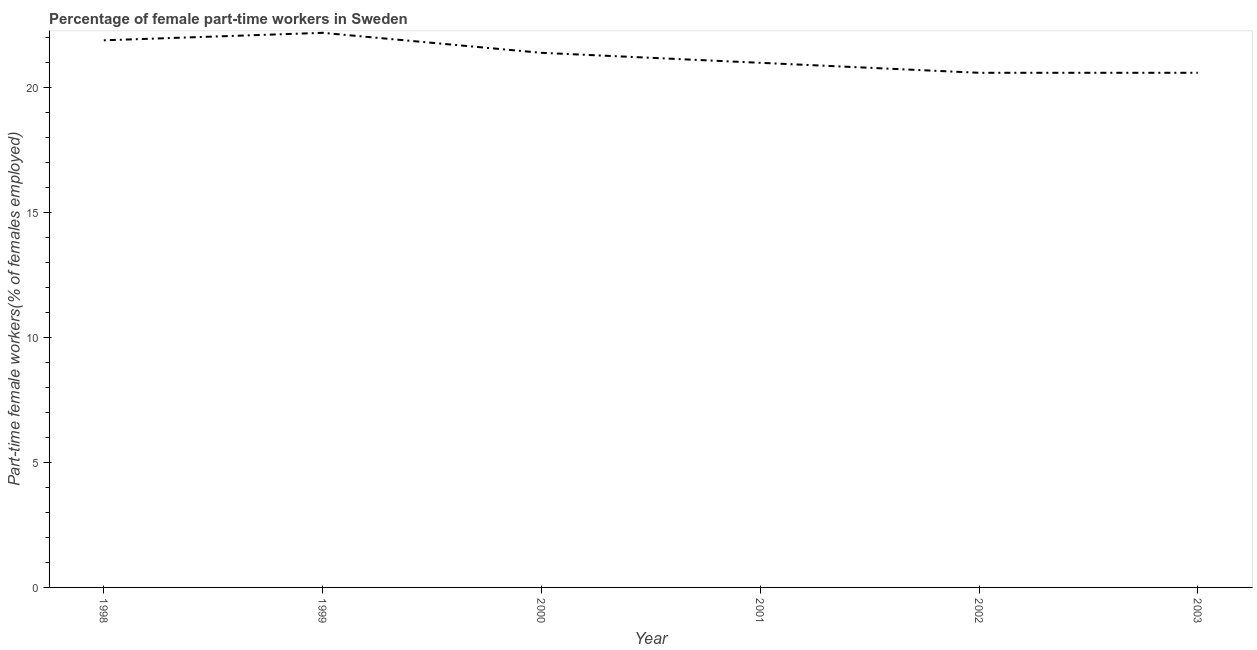What is the percentage of part-time female workers in 1999?
Your answer should be compact. 22.2. Across all years, what is the maximum percentage of part-time female workers?
Your answer should be very brief. 22.2. Across all years, what is the minimum percentage of part-time female workers?
Keep it short and to the point. 20.6. What is the sum of the percentage of part-time female workers?
Offer a terse response. 127.7. What is the difference between the percentage of part-time female workers in 1998 and 2003?
Ensure brevity in your answer.  1.3. What is the average percentage of part-time female workers per year?
Give a very brief answer. 21.28. What is the median percentage of part-time female workers?
Your answer should be compact. 21.2. Do a majority of the years between 2001 and 2000 (inclusive) have percentage of part-time female workers greater than 2 %?
Offer a terse response. No. What is the ratio of the percentage of part-time female workers in 1999 to that in 2001?
Your answer should be very brief. 1.06. What is the difference between the highest and the second highest percentage of part-time female workers?
Your response must be concise. 0.3. Is the sum of the percentage of part-time female workers in 2001 and 2002 greater than the maximum percentage of part-time female workers across all years?
Make the answer very short. Yes. What is the difference between the highest and the lowest percentage of part-time female workers?
Offer a terse response. 1.6. In how many years, is the percentage of part-time female workers greater than the average percentage of part-time female workers taken over all years?
Make the answer very short. 3. How many lines are there?
Provide a succinct answer. 1. How many years are there in the graph?
Ensure brevity in your answer.  6. Does the graph contain any zero values?
Your answer should be compact. No. Does the graph contain grids?
Your answer should be compact. No. What is the title of the graph?
Your answer should be very brief. Percentage of female part-time workers in Sweden. What is the label or title of the Y-axis?
Your answer should be very brief. Part-time female workers(% of females employed). What is the Part-time female workers(% of females employed) of 1998?
Offer a terse response. 21.9. What is the Part-time female workers(% of females employed) of 1999?
Offer a very short reply. 22.2. What is the Part-time female workers(% of females employed) of 2000?
Provide a succinct answer. 21.4. What is the Part-time female workers(% of females employed) in 2001?
Make the answer very short. 21. What is the Part-time female workers(% of females employed) of 2002?
Offer a terse response. 20.6. What is the Part-time female workers(% of females employed) in 2003?
Give a very brief answer. 20.6. What is the difference between the Part-time female workers(% of females employed) in 1998 and 1999?
Ensure brevity in your answer.  -0.3. What is the difference between the Part-time female workers(% of females employed) in 1998 and 2001?
Your response must be concise. 0.9. What is the difference between the Part-time female workers(% of females employed) in 1999 and 2000?
Keep it short and to the point. 0.8. What is the difference between the Part-time female workers(% of females employed) in 1999 and 2001?
Provide a short and direct response. 1.2. What is the difference between the Part-time female workers(% of females employed) in 1999 and 2003?
Your response must be concise. 1.6. What is the difference between the Part-time female workers(% of females employed) in 2000 and 2001?
Make the answer very short. 0.4. What is the difference between the Part-time female workers(% of females employed) in 2000 and 2003?
Make the answer very short. 0.8. What is the difference between the Part-time female workers(% of females employed) in 2001 and 2002?
Your response must be concise. 0.4. What is the difference between the Part-time female workers(% of females employed) in 2002 and 2003?
Your answer should be very brief. 0. What is the ratio of the Part-time female workers(% of females employed) in 1998 to that in 2000?
Your answer should be compact. 1.02. What is the ratio of the Part-time female workers(% of females employed) in 1998 to that in 2001?
Make the answer very short. 1.04. What is the ratio of the Part-time female workers(% of females employed) in 1998 to that in 2002?
Make the answer very short. 1.06. What is the ratio of the Part-time female workers(% of females employed) in 1998 to that in 2003?
Make the answer very short. 1.06. What is the ratio of the Part-time female workers(% of females employed) in 1999 to that in 2000?
Make the answer very short. 1.04. What is the ratio of the Part-time female workers(% of females employed) in 1999 to that in 2001?
Give a very brief answer. 1.06. What is the ratio of the Part-time female workers(% of females employed) in 1999 to that in 2002?
Provide a short and direct response. 1.08. What is the ratio of the Part-time female workers(% of females employed) in 1999 to that in 2003?
Give a very brief answer. 1.08. What is the ratio of the Part-time female workers(% of females employed) in 2000 to that in 2002?
Provide a short and direct response. 1.04. What is the ratio of the Part-time female workers(% of females employed) in 2000 to that in 2003?
Offer a very short reply. 1.04. 